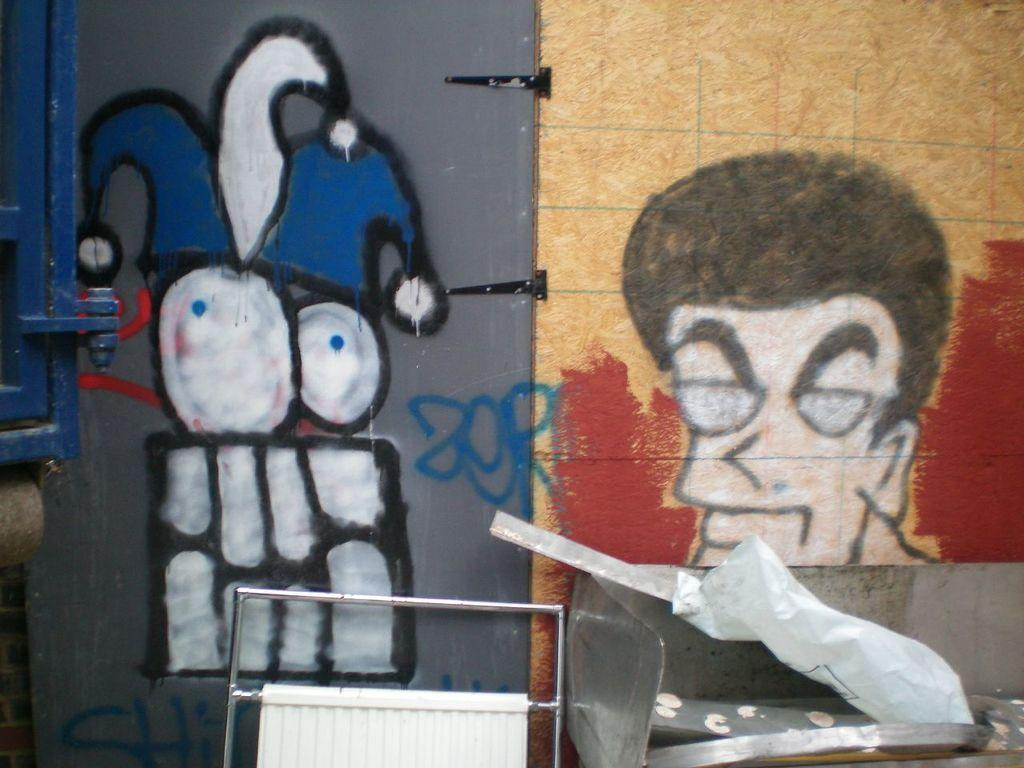What is present on the wall in the image? There is a painting on the wall in the image. What type of furniture is located in the bottom right of the image? There is a metal table in the bottom right of the image. What is covering the table in the image? There is a cover on the table in the image. What object is beside the table in the image? There is a metal rod beside the table in the image. What type of education can be seen in the painting on the wall? The painting on the wall does not depict any educational content; it is an abstract piece. What songs are being sung by the metal rod in the image? The metal rod is an inanimate object and cannot sing songs. 